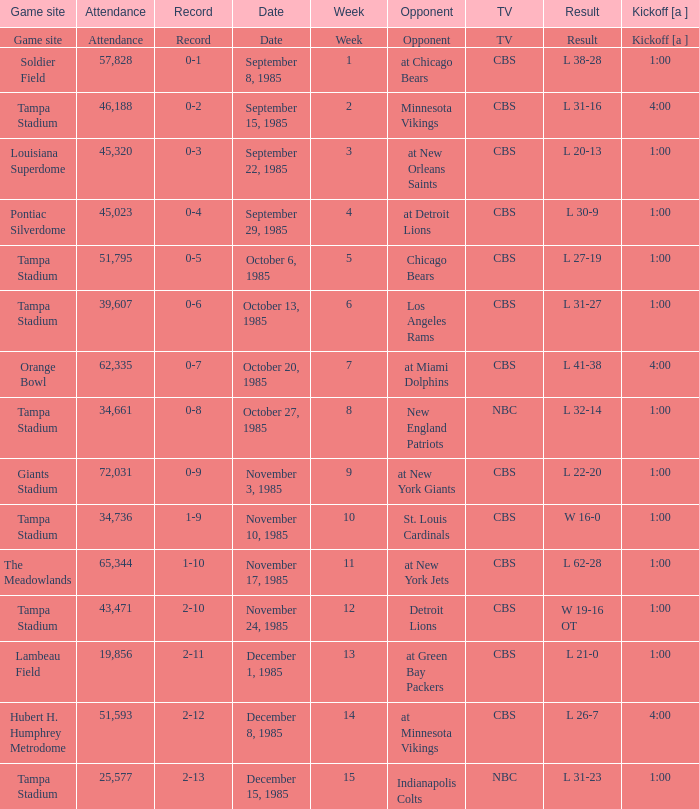Find all the result(s) with the record of 2-13. L 31-23. 